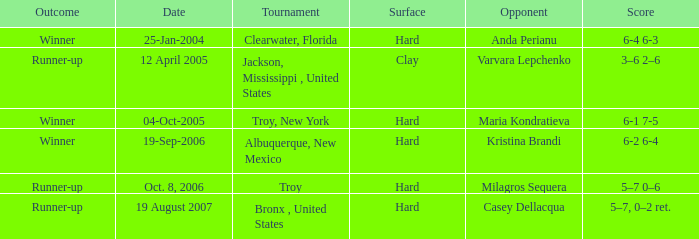Where was the tournament played on Oct. 8, 2006? Troy. 